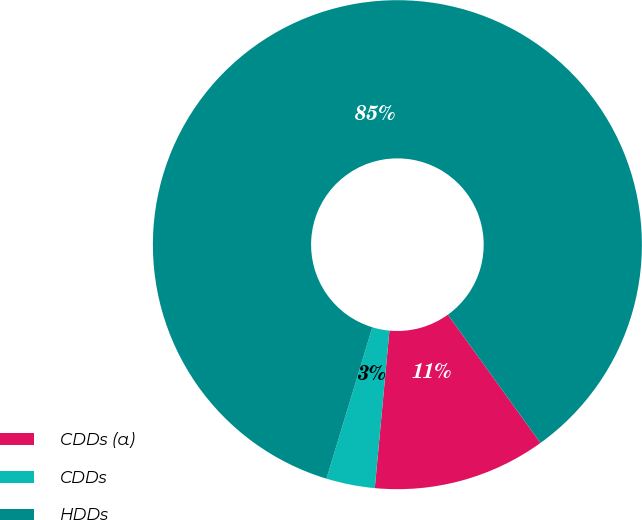Convert chart. <chart><loc_0><loc_0><loc_500><loc_500><pie_chart><fcel>CDDs (a)<fcel>CDDs<fcel>HDDs<nl><fcel>11.42%<fcel>3.21%<fcel>85.37%<nl></chart> 